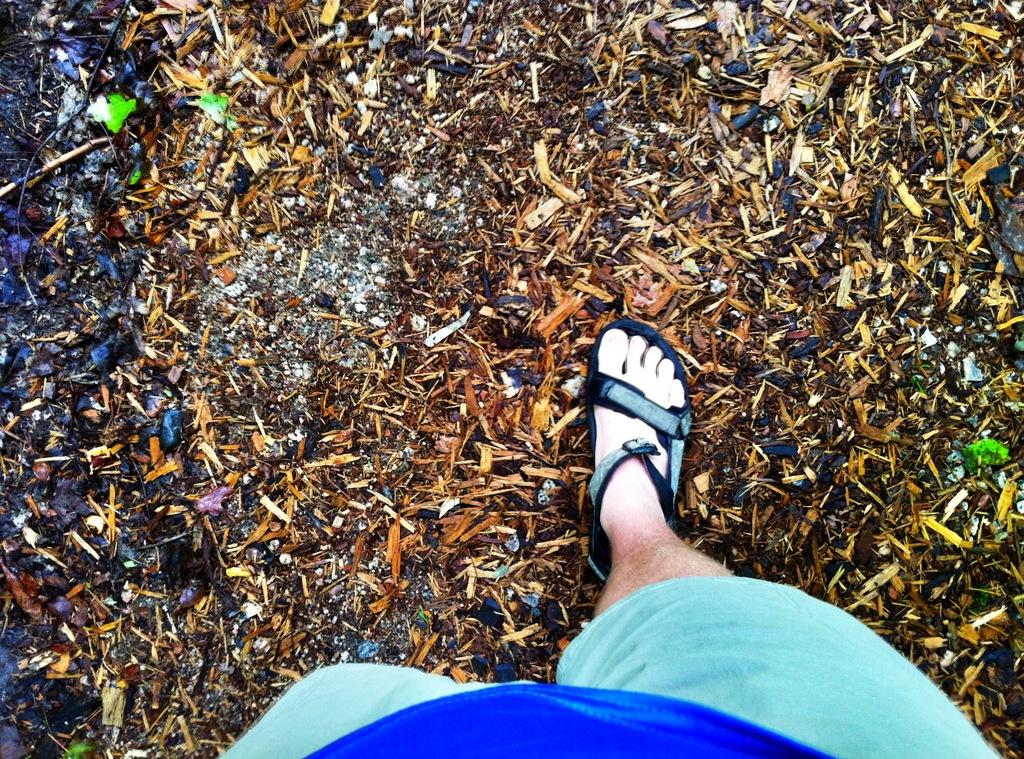What is present in the image? There is a person in the image. Can you describe the person's attire? The person is wearing a blue dress. What type of footwear is the person wearing? The person is wearing footwear. Where is the person standing? The person is standing on the ground. What can be seen on the ground? There are objects on the ground, and they have colors: brown, black, and green. What is the manager's role in the image? There is no mention of a manager in the image, so it is not possible to determine their role. 